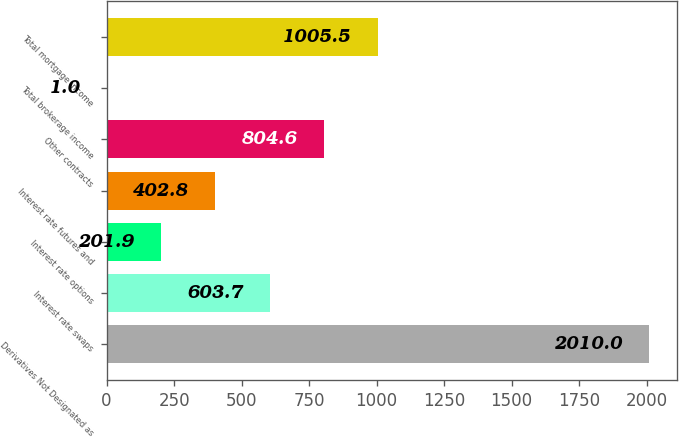Convert chart. <chart><loc_0><loc_0><loc_500><loc_500><bar_chart><fcel>Derivatives Not Designated as<fcel>Interest rate swaps<fcel>Interest rate options<fcel>Interest rate futures and<fcel>Other contracts<fcel>Total brokerage income<fcel>Total mortgage income<nl><fcel>2010<fcel>603.7<fcel>201.9<fcel>402.8<fcel>804.6<fcel>1<fcel>1005.5<nl></chart> 